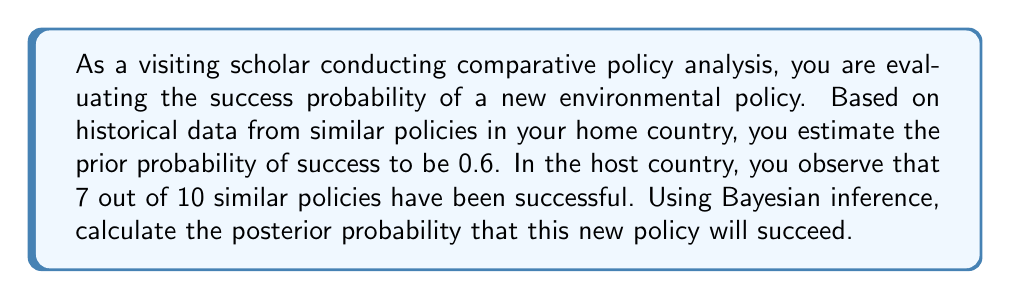Help me with this question. To solve this problem using Bayesian inference, we'll follow these steps:

1. Define our variables:
   $P(S)$ = Prior probability of success = 0.6
   $P(E|S)$ = Likelihood of evidence given success = 7/10 = 0.7
   $P(E|\neg S)$ = Likelihood of evidence given failure = 3/10 = 0.3

2. Apply Bayes' theorem:
   $$P(S|E) = \frac{P(E|S) \cdot P(S)}{P(E)}$$

3. Calculate $P(E)$ using the law of total probability:
   $$P(E) = P(E|S) \cdot P(S) + P(E|\neg S) \cdot P(\neg S)$$
   $$P(E) = 0.7 \cdot 0.6 + 0.3 \cdot 0.4 = 0.42 + 0.12 = 0.54$$

4. Now we can calculate the posterior probability:
   $$P(S|E) = \frac{0.7 \cdot 0.6}{0.54} = \frac{0.42}{0.54} = \frac{7}{9} \approx 0.7778$$

Therefore, the posterior probability of the new policy succeeding, given the evidence from the host country, is approximately 0.7778 or 77.78%.
Answer: The posterior probability that the new environmental policy will succeed is $\frac{7}{9}$ or approximately 0.7778 (77.78%). 